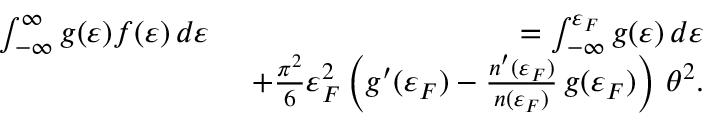Convert formula to latex. <formula><loc_0><loc_0><loc_500><loc_500>\begin{array} { r l r } & { \int _ { - \infty } ^ { \infty } g ( \varepsilon ) f ( \varepsilon ) \, d \varepsilon } & { = \int _ { - \infty } ^ { \varepsilon _ { F } } g ( \varepsilon ) \, d \varepsilon } \\ & { + \frac { \pi ^ { 2 } } { 6 } \varepsilon _ { F } ^ { 2 } \left ( g ^ { \prime } ( \varepsilon _ { F } ) - \frac { n ^ { \prime } ( \varepsilon _ { F } ) } { n ( \varepsilon _ { F } ) } \, g ( \varepsilon _ { F } ) \right ) \, \theta ^ { 2 } . } \end{array}</formula> 